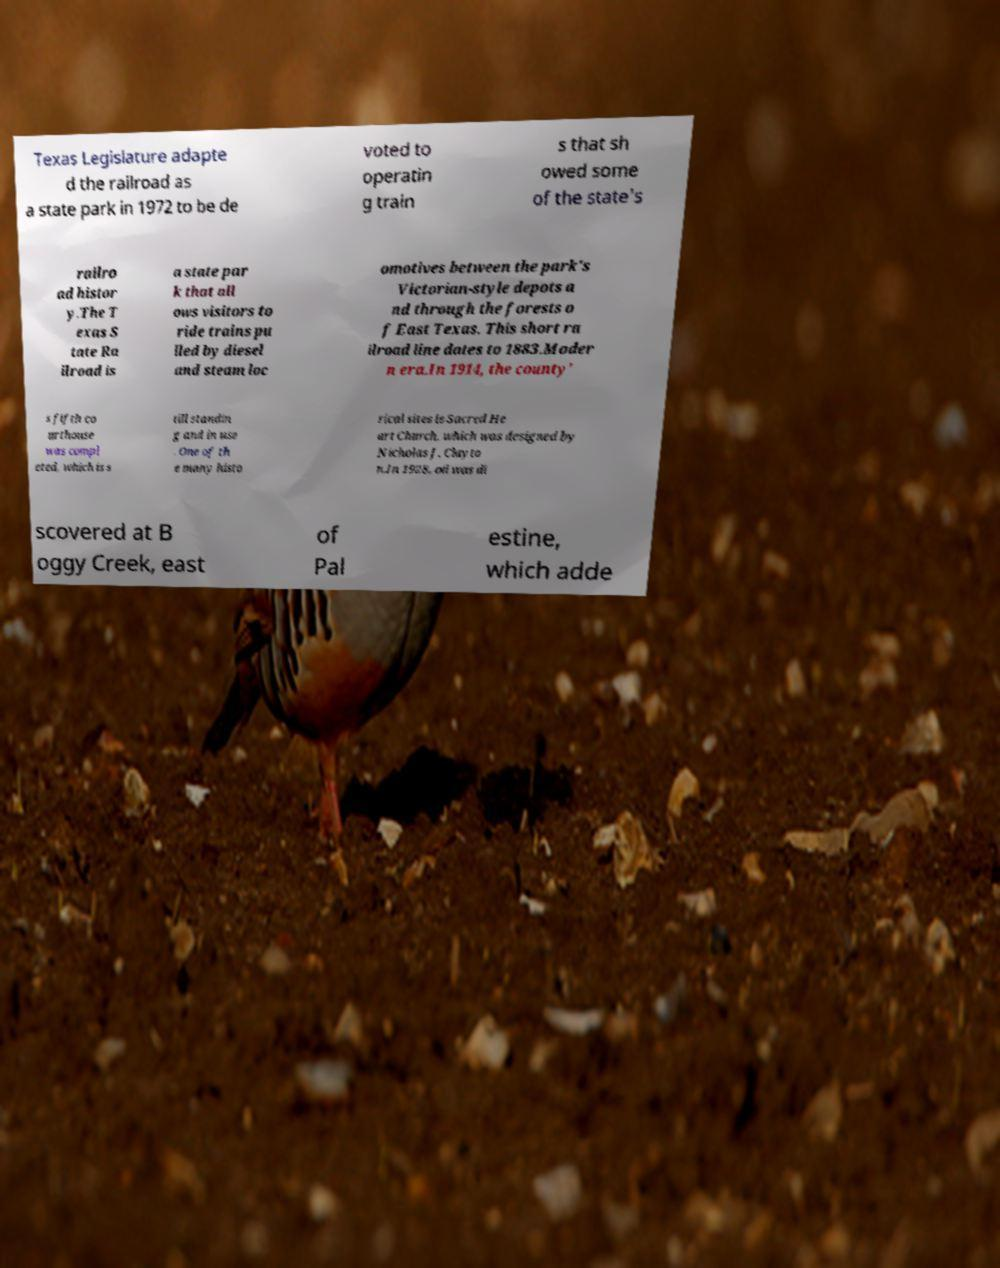What messages or text are displayed in this image? I need them in a readable, typed format. Texas Legislature adapte d the railroad as a state park in 1972 to be de voted to operatin g train s that sh owed some of the state's railro ad histor y.The T exas S tate Ra ilroad is a state par k that all ows visitors to ride trains pu lled by diesel and steam loc omotives between the park's Victorian-style depots a nd through the forests o f East Texas. This short ra ilroad line dates to 1883.Moder n era.In 1914, the county' s fifth co urthouse was compl eted, which is s till standin g and in use . One of th e many histo rical sites is Sacred He art Church, which was designed by Nicholas J. Clayto n.In 1928, oil was di scovered at B oggy Creek, east of Pal estine, which adde 